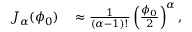Convert formula to latex. <formula><loc_0><loc_0><loc_500><loc_500>\begin{array} { r l } { J _ { \alpha } ( \phi _ { 0 } ) } & \approx \frac { 1 } { ( \alpha - 1 ) ! } \left ( \frac { \phi _ { 0 } } { 2 } \right ) ^ { \alpha } , } \end{array}</formula> 